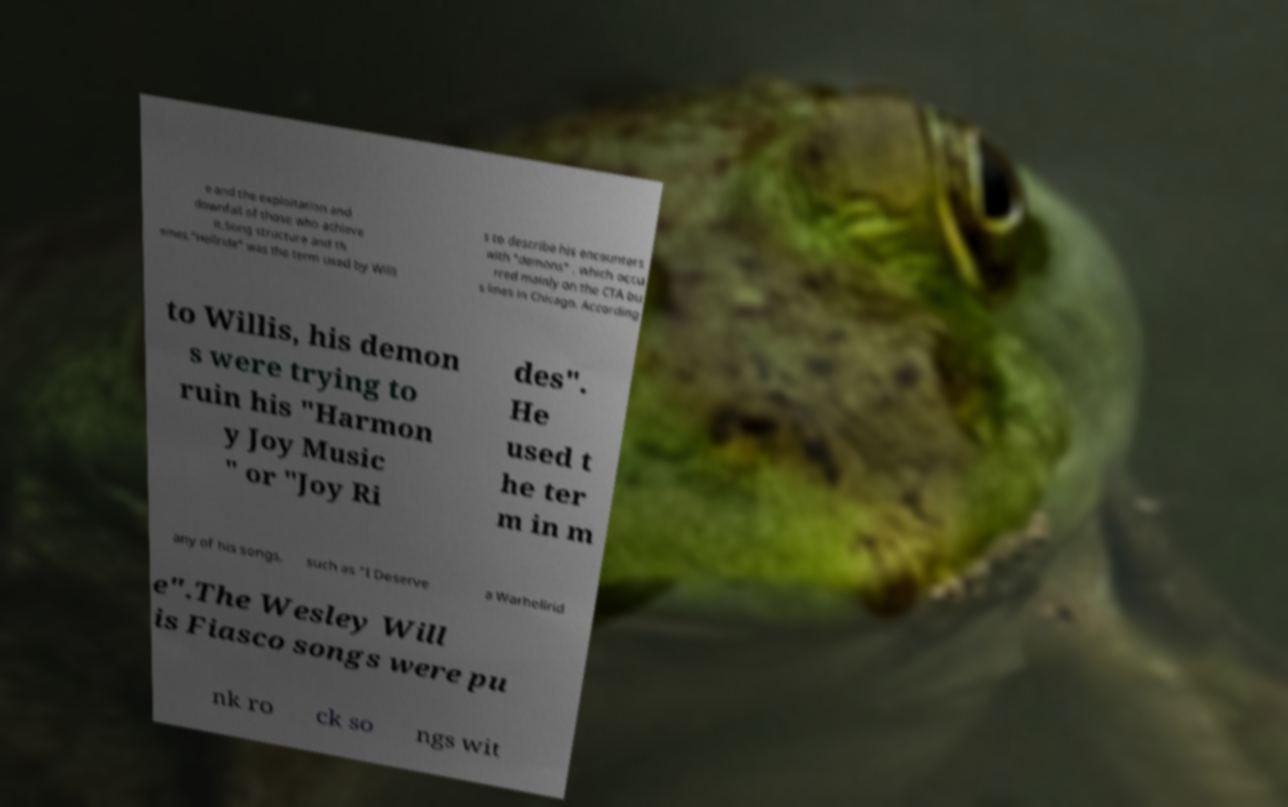Please read and relay the text visible in this image. What does it say? e and the exploitation and downfall of those who achieve it.Song structure and th emes."Hellride" was the term used by Willi s to describe his encounters with "demons" , which occu rred mainly on the CTA bu s lines in Chicago. According to Willis, his demon s were trying to ruin his "Harmon y Joy Music " or "Joy Ri des". He used t he ter m in m any of his songs, such as "I Deserve a Warhellrid e".The Wesley Will is Fiasco songs were pu nk ro ck so ngs wit 